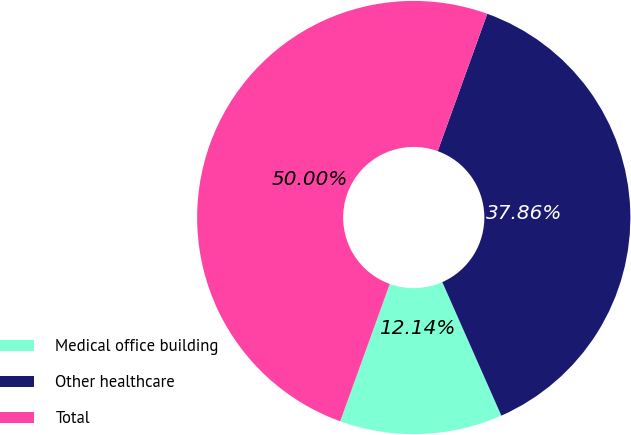Convert chart to OTSL. <chart><loc_0><loc_0><loc_500><loc_500><pie_chart><fcel>Medical office building<fcel>Other healthcare<fcel>Total<nl><fcel>12.14%<fcel>37.86%<fcel>50.0%<nl></chart> 